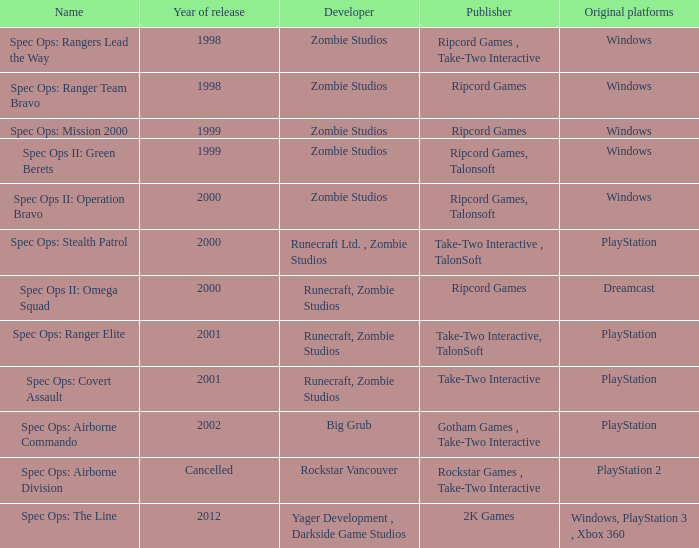Which publisher has a 2000 release year and an initial dreamcast platform? Ripcord Games. Write the full table. {'header': ['Name', 'Year of release', 'Developer', 'Publisher', 'Original platforms'], 'rows': [['Spec Ops: Rangers Lead the Way', '1998', 'Zombie Studios', 'Ripcord Games , Take-Two Interactive', 'Windows'], ['Spec Ops: Ranger Team Bravo', '1998', 'Zombie Studios', 'Ripcord Games', 'Windows'], ['Spec Ops: Mission 2000', '1999', 'Zombie Studios', 'Ripcord Games', 'Windows'], ['Spec Ops II: Green Berets', '1999', 'Zombie Studios', 'Ripcord Games, Talonsoft', 'Windows'], ['Spec Ops II: Operation Bravo', '2000', 'Zombie Studios', 'Ripcord Games, Talonsoft', 'Windows'], ['Spec Ops: Stealth Patrol', '2000', 'Runecraft Ltd. , Zombie Studios', 'Take-Two Interactive , TalonSoft', 'PlayStation'], ['Spec Ops II: Omega Squad', '2000', 'Runecraft, Zombie Studios', 'Ripcord Games', 'Dreamcast'], ['Spec Ops: Ranger Elite', '2001', 'Runecraft, Zombie Studios', 'Take-Two Interactive, TalonSoft', 'PlayStation'], ['Spec Ops: Covert Assault', '2001', 'Runecraft, Zombie Studios', 'Take-Two Interactive', 'PlayStation'], ['Spec Ops: Airborne Commando', '2002', 'Big Grub', 'Gotham Games , Take-Two Interactive', 'PlayStation'], ['Spec Ops: Airborne Division', 'Cancelled', 'Rockstar Vancouver', 'Rockstar Games , Take-Two Interactive', 'PlayStation 2'], ['Spec Ops: The Line', '2012', 'Yager Development , Darkside Game Studios', '2K Games', 'Windows, PlayStation 3 , Xbox 360']]} 